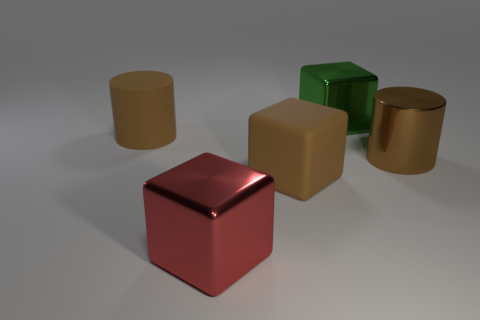Add 3 large brown matte cylinders. How many objects exist? 8 Subtract all cylinders. How many objects are left? 3 Add 4 brown objects. How many brown objects are left? 7 Add 1 small brown cylinders. How many small brown cylinders exist? 1 Subtract 1 brown cubes. How many objects are left? 4 Subtract all big yellow spheres. Subtract all cylinders. How many objects are left? 3 